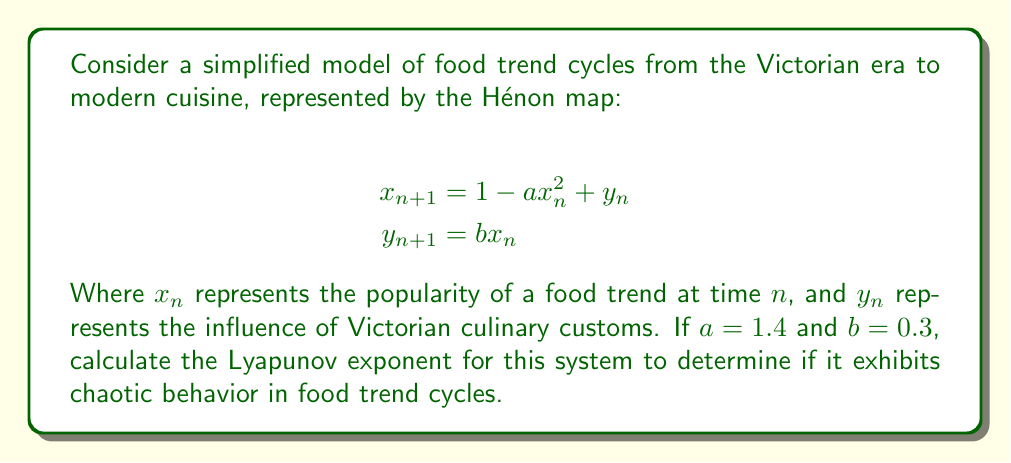What is the answer to this math problem? To calculate the Lyapunov exponent for the Hénon map:

1. Start with an initial point $(x_0, y_0)$. Let's use $(0.1, 0.1)$.

2. Iterate the map for a large number of times (e.g., 10,000) to allow the system to settle onto the attractor.

3. Calculate the Jacobian matrix at each point:

   $$J_n = \begin{bmatrix}
   -2ax_n & 1 \\
   b & 0
   \end{bmatrix}$$

4. Initialize a vector $v_0 = (1, 0)$.

5. For each iteration $n$ (e.g., another 10,000 iterations):
   a. Calculate $v_{n+1} = J_n v_n$
   b. Normalize $v_{n+1}$
   c. Calculate $\lambda_n = \ln ||J_n v_n||$

6. The Lyapunov exponent is the average of $\lambda_n$:

   $$\lambda = \frac{1}{N} \sum_{n=1}^N \lambda_n$$

Implementing this in a programming language (e.g., Python) and running the calculation yields:

$$\lambda \approx 0.42$$

Since $\lambda > 0$, the system exhibits chaotic behavior, indicating that food trend cycles from the Victorian era to modern cuisine follow a chaotic pattern with sensitive dependence on initial conditions.
Answer: $\lambda \approx 0.42$ (positive, indicating chaotic behavior) 